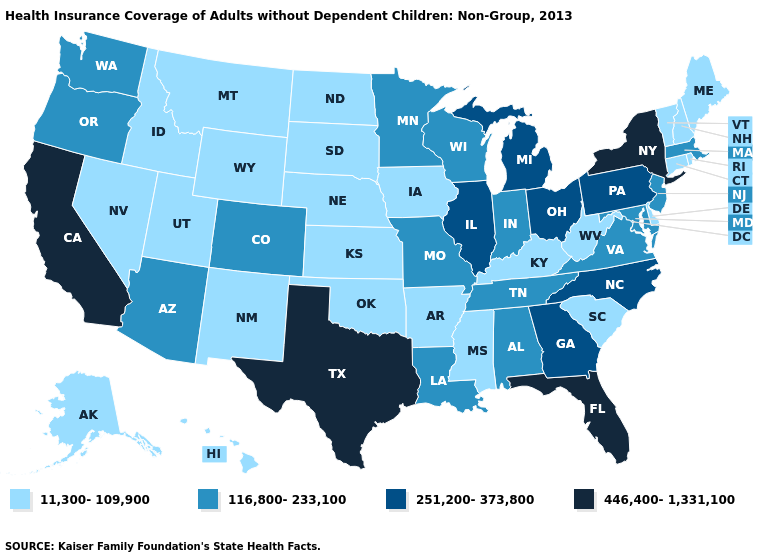How many symbols are there in the legend?
Keep it brief. 4. Is the legend a continuous bar?
Concise answer only. No. Which states have the lowest value in the MidWest?
Quick response, please. Iowa, Kansas, Nebraska, North Dakota, South Dakota. Which states have the highest value in the USA?
Quick response, please. California, Florida, New York, Texas. Among the states that border North Dakota , which have the lowest value?
Keep it brief. Montana, South Dakota. What is the value of Wyoming?
Write a very short answer. 11,300-109,900. What is the value of Illinois?
Concise answer only. 251,200-373,800. What is the highest value in the South ?
Keep it brief. 446,400-1,331,100. What is the value of Utah?
Give a very brief answer. 11,300-109,900. Does the first symbol in the legend represent the smallest category?
Write a very short answer. Yes. What is the highest value in states that border Arizona?
Concise answer only. 446,400-1,331,100. Is the legend a continuous bar?
Be succinct. No. Name the states that have a value in the range 251,200-373,800?
Be succinct. Georgia, Illinois, Michigan, North Carolina, Ohio, Pennsylvania. Name the states that have a value in the range 446,400-1,331,100?
Answer briefly. California, Florida, New York, Texas. What is the lowest value in the USA?
Answer briefly. 11,300-109,900. 